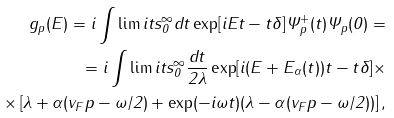<formula> <loc_0><loc_0><loc_500><loc_500>g _ { p } ( E ) = i \int \lim i t s _ { 0 } ^ { \infty } d t \exp [ i E t - t \delta ] \Psi ^ { + } _ { p } ( t ) \Psi _ { p } ( 0 ) = \\ = i \int \lim i t s _ { 0 } ^ { \infty } \frac { d t } { 2 \lambda } \exp [ i ( E + E _ { \alpha } ( t ) ) t - t \delta ] \times \\ \times \left [ \lambda + \alpha ( v _ { F } p - \omega / 2 ) + \exp ( - i \omega t ) ( \lambda - \alpha ( v _ { F } p - \omega / 2 ) ) \right ] ,</formula> 